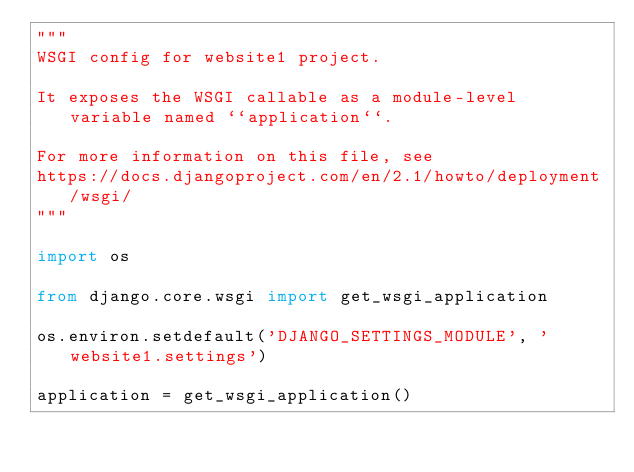Convert code to text. <code><loc_0><loc_0><loc_500><loc_500><_Python_>"""
WSGI config for website1 project.

It exposes the WSGI callable as a module-level variable named ``application``.

For more information on this file, see
https://docs.djangoproject.com/en/2.1/howto/deployment/wsgi/
"""

import os

from django.core.wsgi import get_wsgi_application

os.environ.setdefault('DJANGO_SETTINGS_MODULE', 'website1.settings')

application = get_wsgi_application()
</code> 